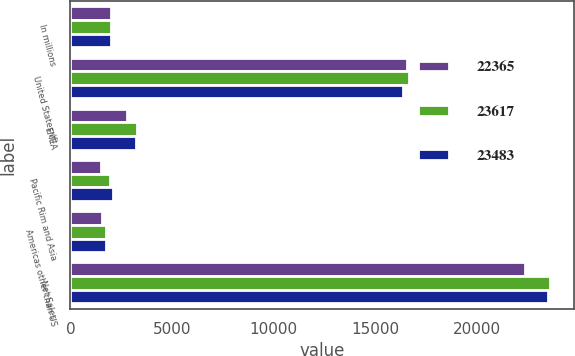<chart> <loc_0><loc_0><loc_500><loc_500><stacked_bar_chart><ecel><fcel>In millions<fcel>United States (f)<fcel>EMEA<fcel>Pacific Rim and Asia<fcel>Americas other than US<fcel>Net Sales<nl><fcel>22365<fcel>2015<fcel>16554<fcel>2770<fcel>1501<fcel>1540<fcel>22365<nl><fcel>23617<fcel>2014<fcel>16645<fcel>3273<fcel>1951<fcel>1748<fcel>23617<nl><fcel>23483<fcel>2013<fcel>16371<fcel>3250<fcel>2114<fcel>1748<fcel>23483<nl></chart> 